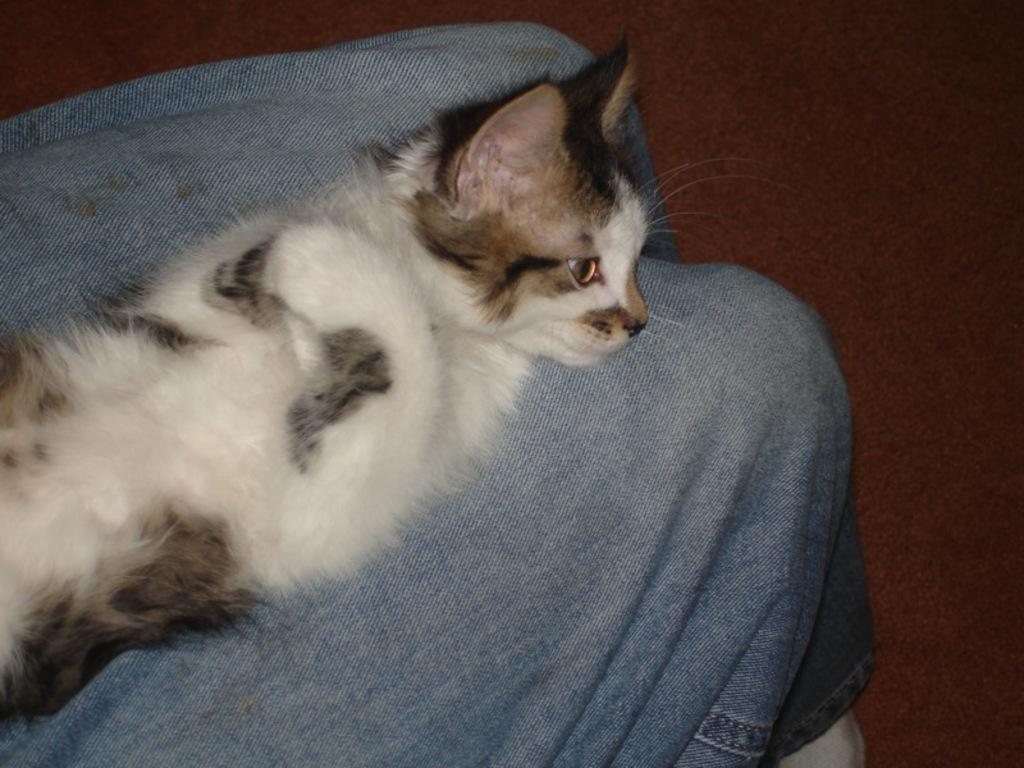What type of animal is in the image? There is a cat in the image. Where is the cat located in the image? The cat is on a surface. What type of arch can be seen in the image? There is no arch present in the image; it features a cat on a surface. What type of lunch is the robin eating in the image? There is no robin or lunch present in the image; it features a cat on a surface. 